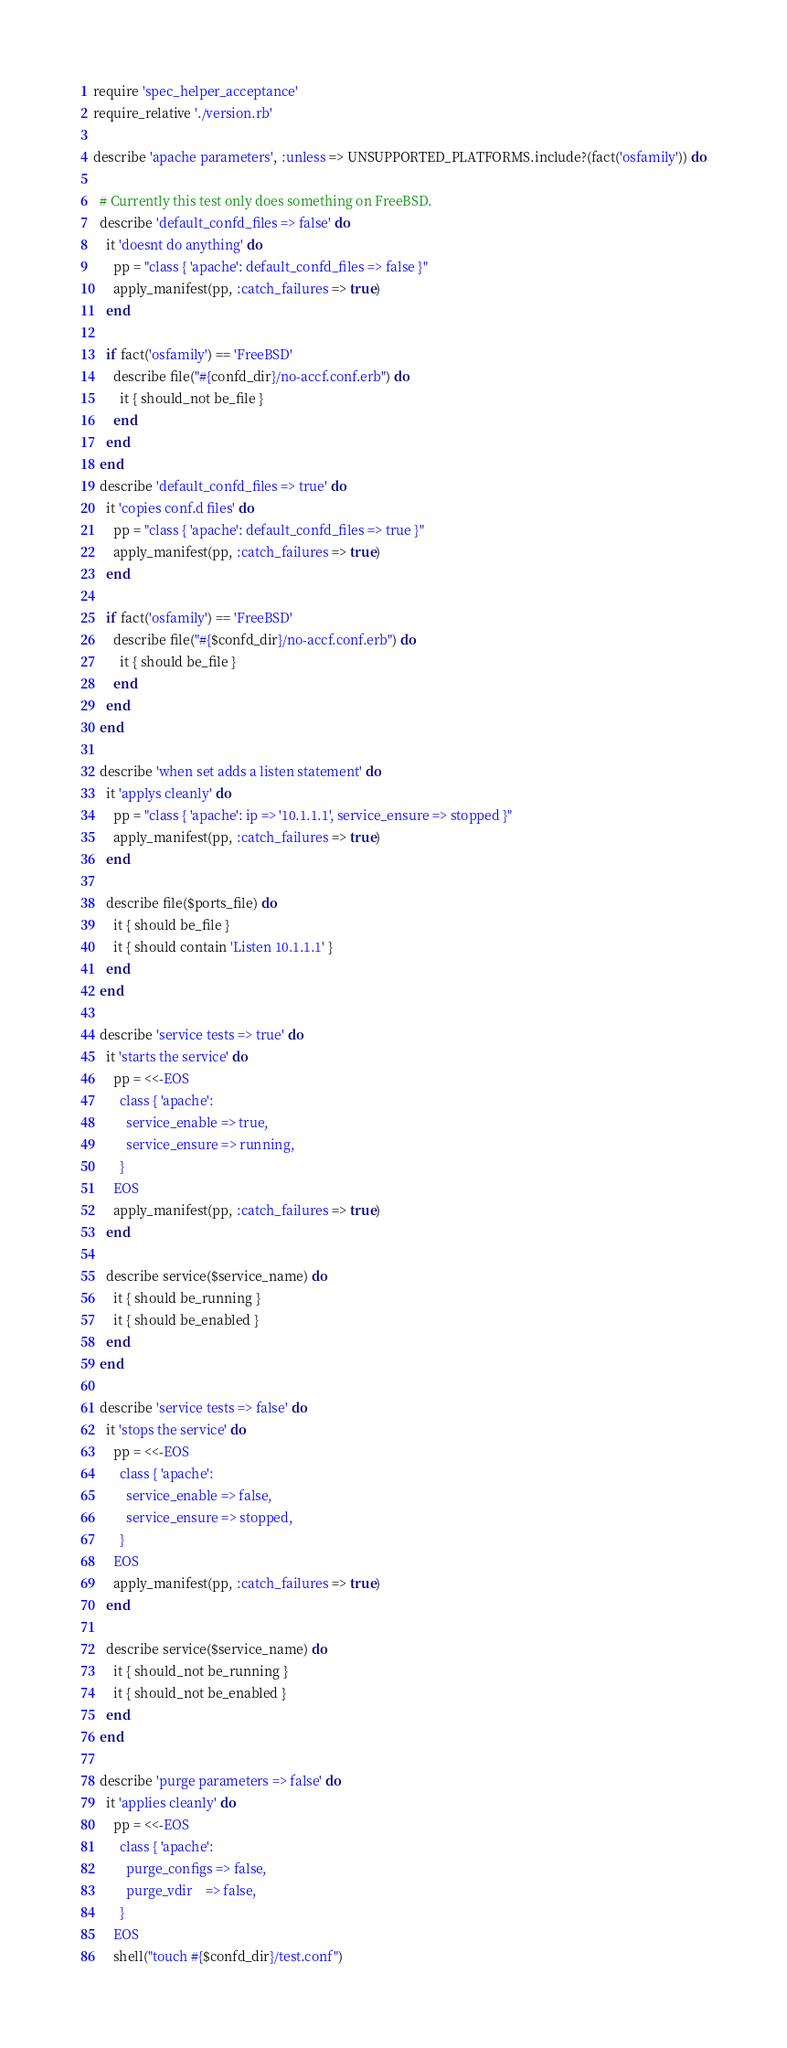<code> <loc_0><loc_0><loc_500><loc_500><_Ruby_>require 'spec_helper_acceptance'
require_relative './version.rb'

describe 'apache parameters', :unless => UNSUPPORTED_PLATFORMS.include?(fact('osfamily')) do

  # Currently this test only does something on FreeBSD.
  describe 'default_confd_files => false' do
    it 'doesnt do anything' do
      pp = "class { 'apache': default_confd_files => false }"
      apply_manifest(pp, :catch_failures => true)
    end

    if fact('osfamily') == 'FreeBSD'
      describe file("#{confd_dir}/no-accf.conf.erb") do
        it { should_not be_file }
      end
    end
  end
  describe 'default_confd_files => true' do
    it 'copies conf.d files' do
      pp = "class { 'apache': default_confd_files => true }"
      apply_manifest(pp, :catch_failures => true)
    end

    if fact('osfamily') == 'FreeBSD'
      describe file("#{$confd_dir}/no-accf.conf.erb") do
        it { should be_file }
      end
    end
  end

  describe 'when set adds a listen statement' do
    it 'applys cleanly' do
      pp = "class { 'apache': ip => '10.1.1.1', service_ensure => stopped }"
      apply_manifest(pp, :catch_failures => true)
    end

    describe file($ports_file) do
      it { should be_file }
      it { should contain 'Listen 10.1.1.1' }
    end
  end

  describe 'service tests => true' do
    it 'starts the service' do
      pp = <<-EOS
        class { 'apache':
          service_enable => true,
          service_ensure => running,
        }
      EOS
      apply_manifest(pp, :catch_failures => true)
    end

    describe service($service_name) do
      it { should be_running }
      it { should be_enabled }
    end
  end

  describe 'service tests => false' do
    it 'stops the service' do
      pp = <<-EOS
        class { 'apache':
          service_enable => false,
          service_ensure => stopped,
        }
      EOS
      apply_manifest(pp, :catch_failures => true)
    end

    describe service($service_name) do
      it { should_not be_running }
      it { should_not be_enabled }
    end
  end

  describe 'purge parameters => false' do
    it 'applies cleanly' do
      pp = <<-EOS
        class { 'apache':
          purge_configs => false,
          purge_vdir    => false,
        }
      EOS
      shell("touch #{$confd_dir}/test.conf")</code> 